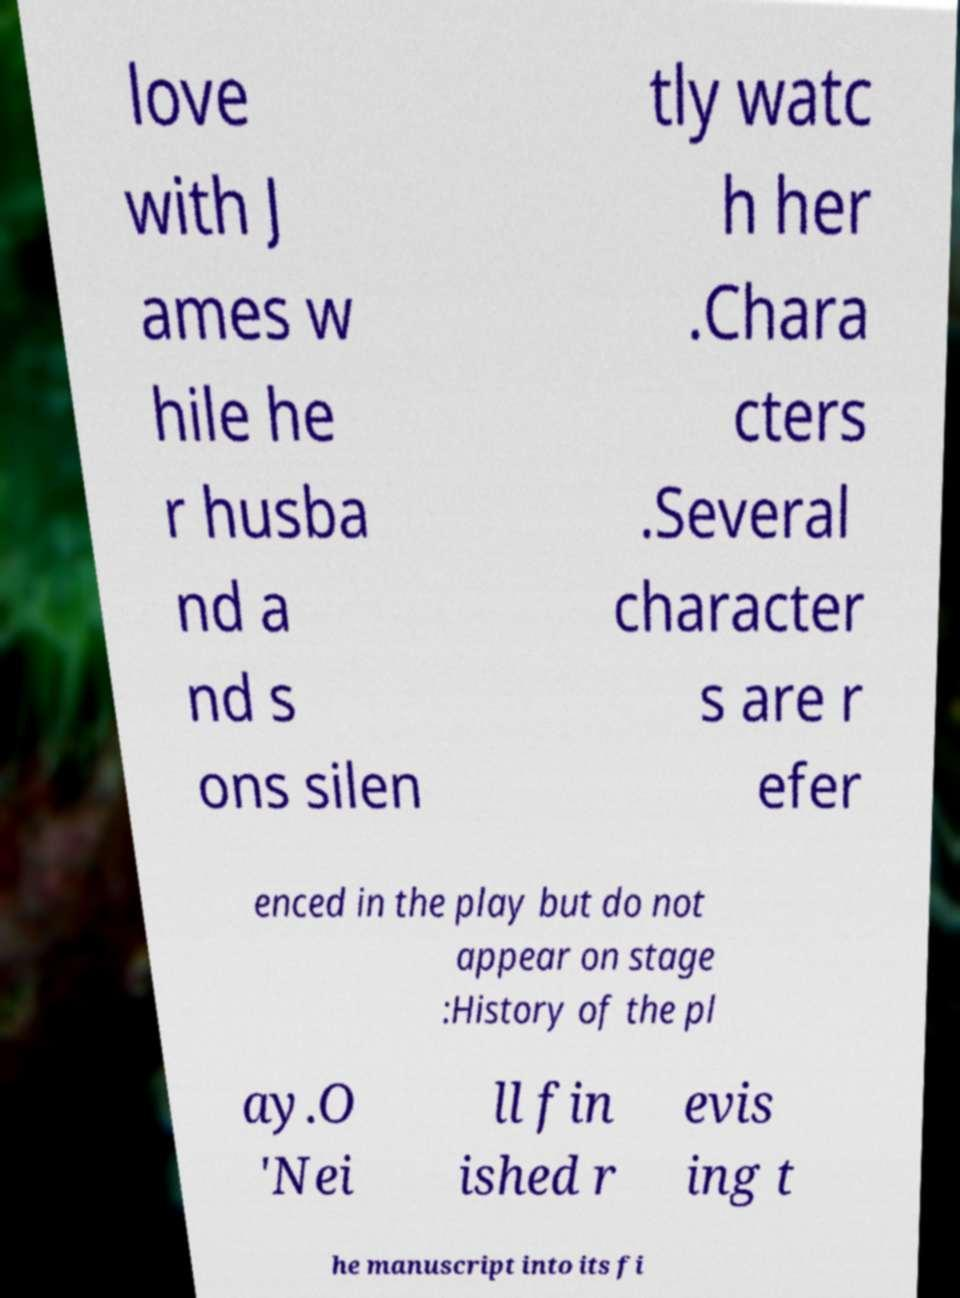Please identify and transcribe the text found in this image. love with J ames w hile he r husba nd a nd s ons silen tly watc h her .Chara cters .Several character s are r efer enced in the play but do not appear on stage :History of the pl ay.O 'Nei ll fin ished r evis ing t he manuscript into its fi 